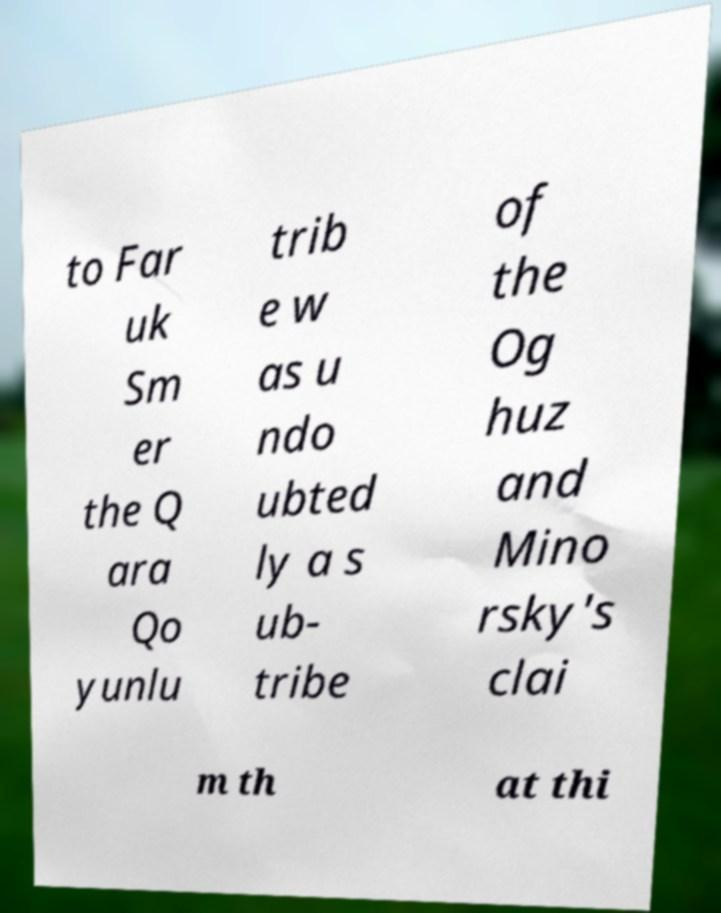Please identify and transcribe the text found in this image. to Far uk Sm er the Q ara Qo yunlu trib e w as u ndo ubted ly a s ub- tribe of the Og huz and Mino rsky's clai m th at thi 